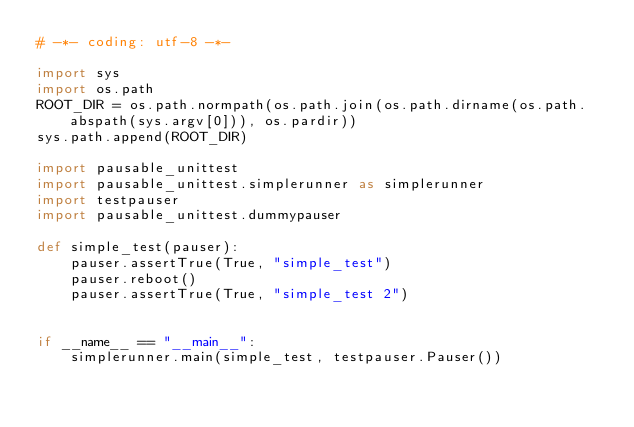Convert code to text. <code><loc_0><loc_0><loc_500><loc_500><_Python_># -*- coding: utf-8 -*-

import sys
import os.path
ROOT_DIR = os.path.normpath(os.path.join(os.path.dirname(os.path.abspath(sys.argv[0])), os.pardir))
sys.path.append(ROOT_DIR)

import pausable_unittest
import pausable_unittest.simplerunner as simplerunner
import testpauser
import pausable_unittest.dummypauser

def simple_test(pauser):
    pauser.assertTrue(True, "simple_test")
    pauser.reboot()
    pauser.assertTrue(True, "simple_test 2")


if __name__ == "__main__":
    simplerunner.main(simple_test, testpauser.Pauser())
</code> 